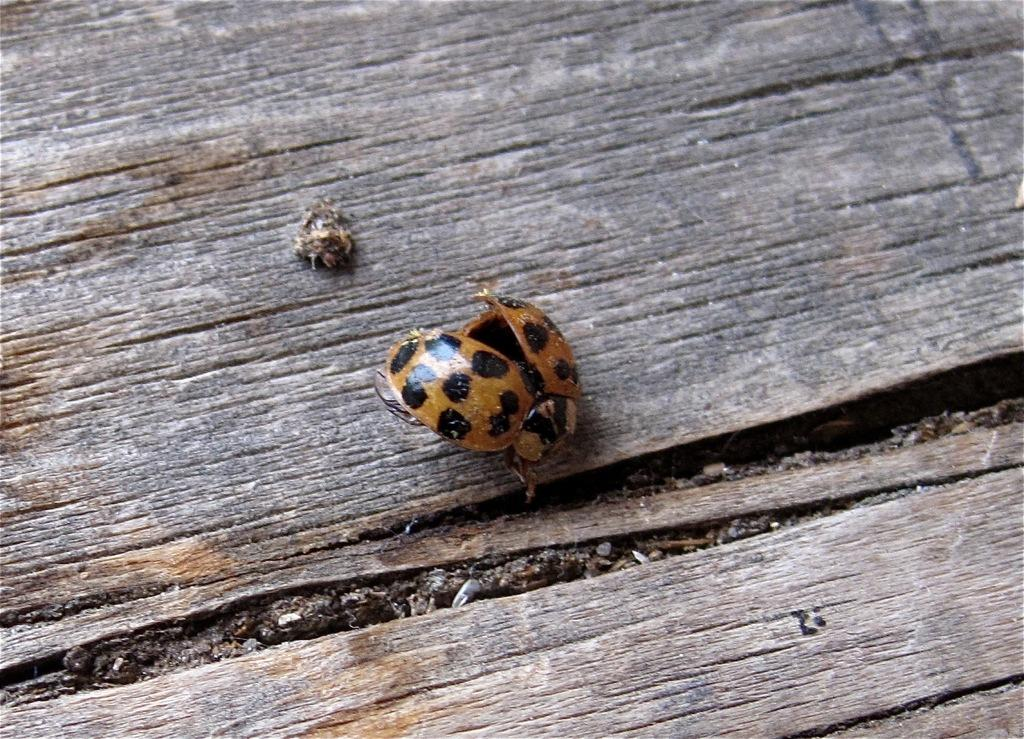What type of creatures can be seen in the image? There are insects in the image. What surface are the insects located on? The insects are on a wooden surface. How many dogs are visible in the image? There are no dogs present in the image; it features insects on a wooden surface. What type of lipstick is being used by the insects in the image? There is no lipstick or any cosmetic product visible in the image, as it features insects on a wooden surface. 